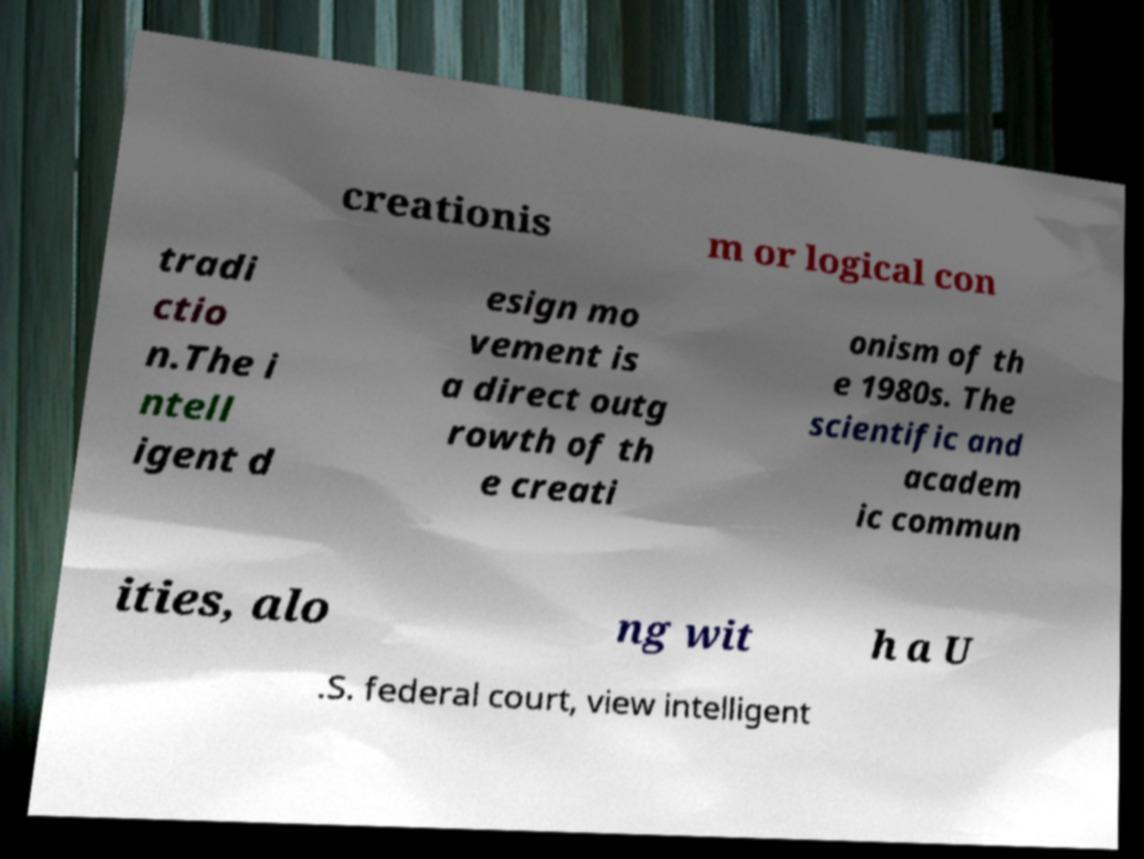Could you extract and type out the text from this image? creationis m or logical con tradi ctio n.The i ntell igent d esign mo vement is a direct outg rowth of th e creati onism of th e 1980s. The scientific and academ ic commun ities, alo ng wit h a U .S. federal court, view intelligent 